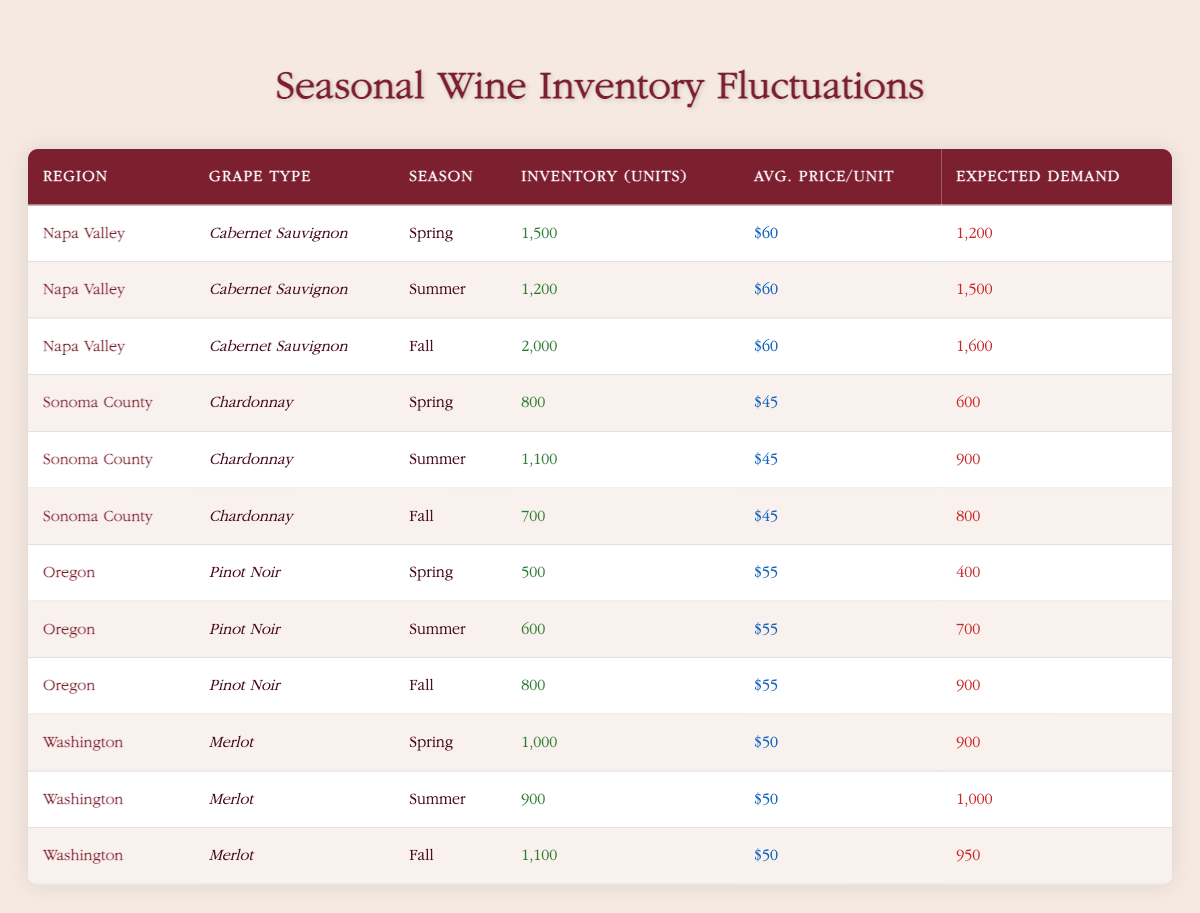What is the expected demand for Cabernet Sauvignon in Napa Valley during Summer? The table indicates that for the Cabernet Sauvignon in Napa Valley, the expected demand during the Summer season is listed directly under the "Expected Demand" column. The value is 1500.
Answer: 1500 What is the total inventory of Chardonnay across all seasons in Sonoma County? The inventory for Chardonnay in Sonoma County is as follows: Spring (800), Summer (1100), and Fall (700). To find the total inventory, we sum these values: 800 + 1100 + 700 = 2600.
Answer: 2600 Is the average price per unit of Merlot in Washington the same across all seasons? Looking at the "Avg. Price/Unit" for Merlot in Washington across Spring ($50), Summer ($50), and Fall ($50), we can see that the price remains unchanged across all seasons. Therefore, the answer is yes.
Answer: Yes How does the inventory of Pinot Noir in Oregon change from Spring to Fall? The inventory of Pinot Noir in Oregon is 500 units in Spring, 600 units in Summer, and increases to 800 units in Fall. This shows an increase of 300 units from Spring to Fall. Therefore, the inventory shows growth across these seasons.
Answer: Increased by 300 units What is the average expected demand for wine in the Spring across all regions and grape types? The expected demand in Spring is as follows: Cabernet Sauvignon (1200), Chardonnay (600), Pinot Noir (400), Merlot (900). To calculate the average, we first sum these demands: 1200 + 600 + 400 + 900 = 3100. Then we divide by the total number of entries (4): 3100 / 4 = 775.
Answer: 775 What is the inventory unit that is highest among all grape types and regions in Summer? During Summer, the inventory units are: Cabernet Sauvignon (1200), Chardonnay (1100), Pinot Noir (600), Merlot (900). The highest value among these is 1200 units for the Cabernet Sauvignon in Napa Valley.
Answer: 1200 Are there more total inventory units of Cabernet Sauvignon in Napa Valley during Fall than the total expected demand in Summer across all grape types? The total inventory of Cabernet Sauvignon in Napa Valley during Fall is 2000 units, while the total expected demand in Summer (Cabernet Sauvignon 1500, Chardonnay 900, Pinot Noir 700, and Merlot 1000) adds up to 4100 units. Thus, 2000 is less than 4100.
Answer: No What are the average price per unit and total expected demand for wines across all regions in Fall? The average price per unit across all regions in Fall is: Cabernet Sauvignon ($60), Chardonnay ($45), Pinot Noir ($55), and Merlot ($50). We calculate the average: (60 + 45 + 55 + 50) / 4 = 52.5. The total expected demand in Fall is 1600 + 800 + 900 + 950 = 4350.
Answer: Average price: 52.5; Total demand: 4350 